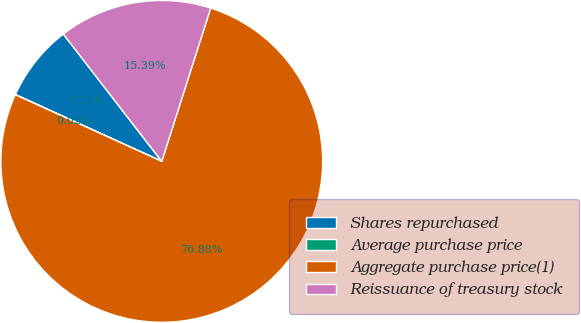<chart> <loc_0><loc_0><loc_500><loc_500><pie_chart><fcel>Shares repurchased<fcel>Average purchase price<fcel>Aggregate purchase price(1)<fcel>Reissuance of treasury stock<nl><fcel>7.71%<fcel>0.02%<fcel>76.88%<fcel>15.39%<nl></chart> 